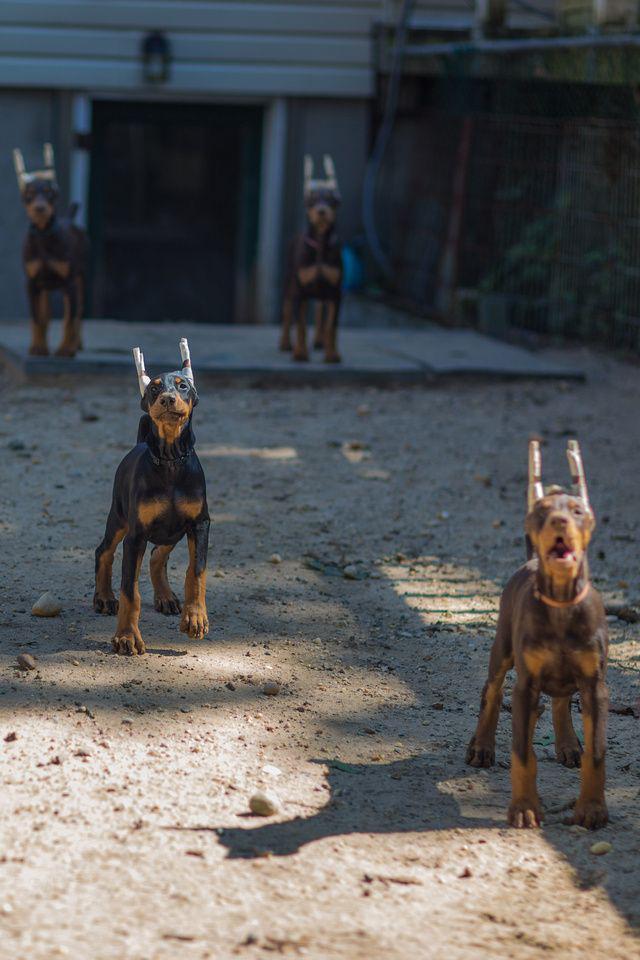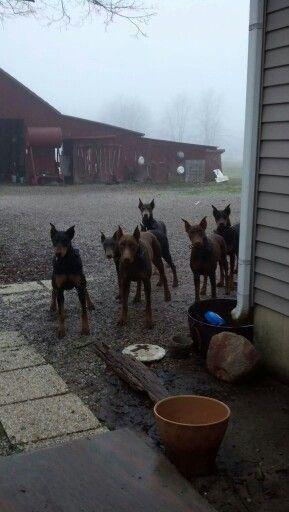The first image is the image on the left, the second image is the image on the right. For the images displayed, is the sentence "An image shows a person at the center of an outdoor scene, surrounded by a group of pointy-eared adult dobermans wearing collars." factually correct? Answer yes or no. No. The first image is the image on the left, the second image is the image on the right. Assess this claim about the two images: "There are more dogs in the left image than in the right image.". Correct or not? Answer yes or no. No. 